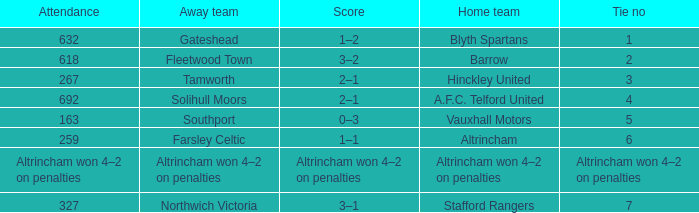What home team had 2 ties? Barrow. 